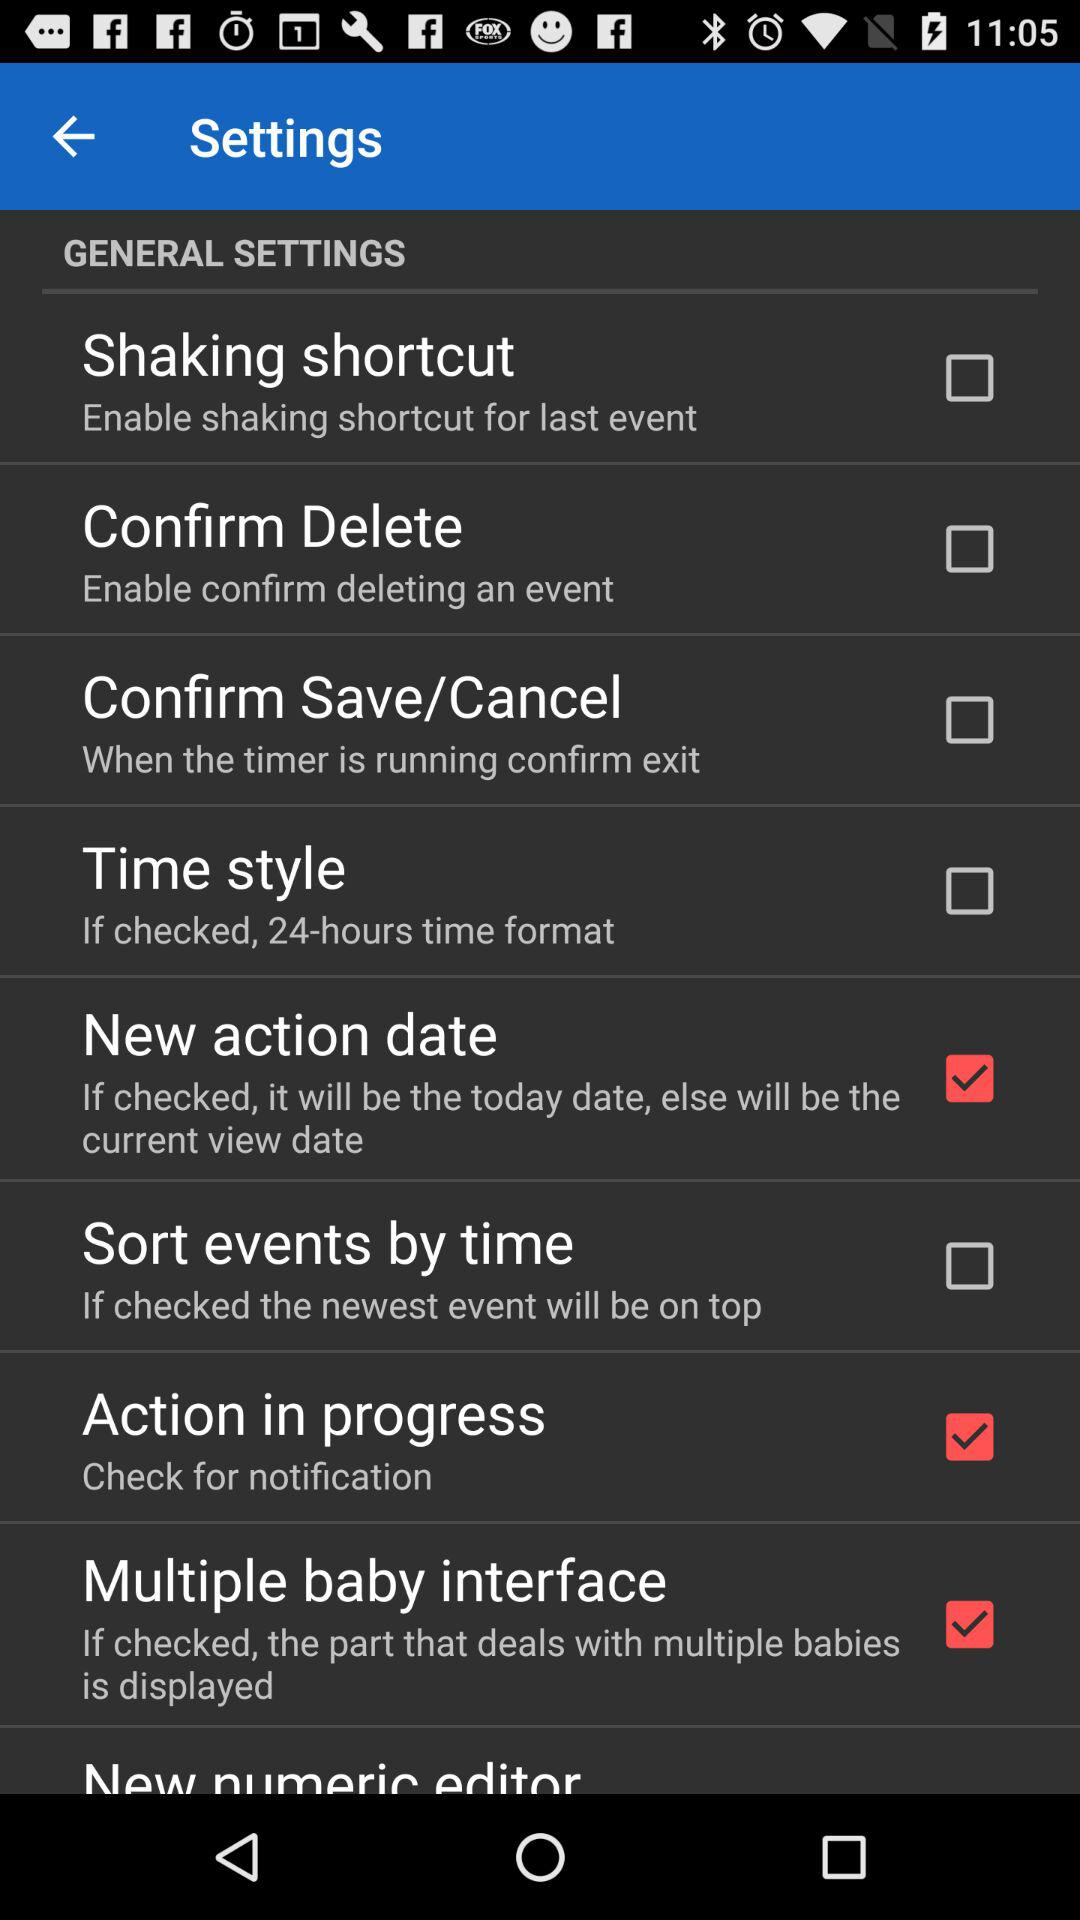What is the status of "Action in progress"? The status is "on". 